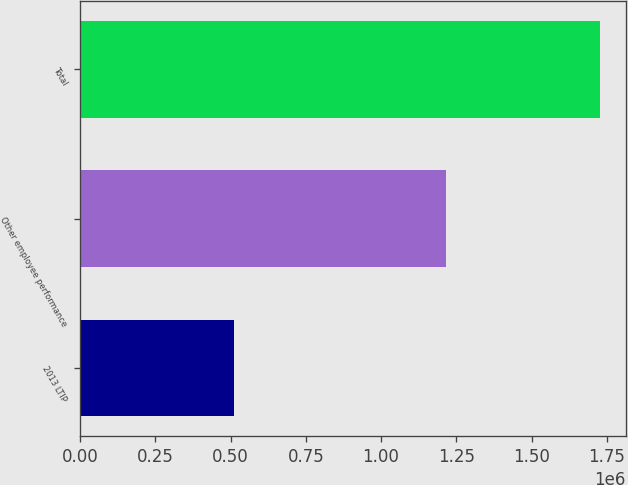Convert chart. <chart><loc_0><loc_0><loc_500><loc_500><bar_chart><fcel>2013 LTIP<fcel>Other employee performance<fcel>Total<nl><fcel>510750<fcel>1.2155e+06<fcel>1.72625e+06<nl></chart> 